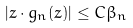<formula> <loc_0><loc_0><loc_500><loc_500>| z \cdot g _ { n } ( z ) | \leq C \beta _ { n }</formula> 